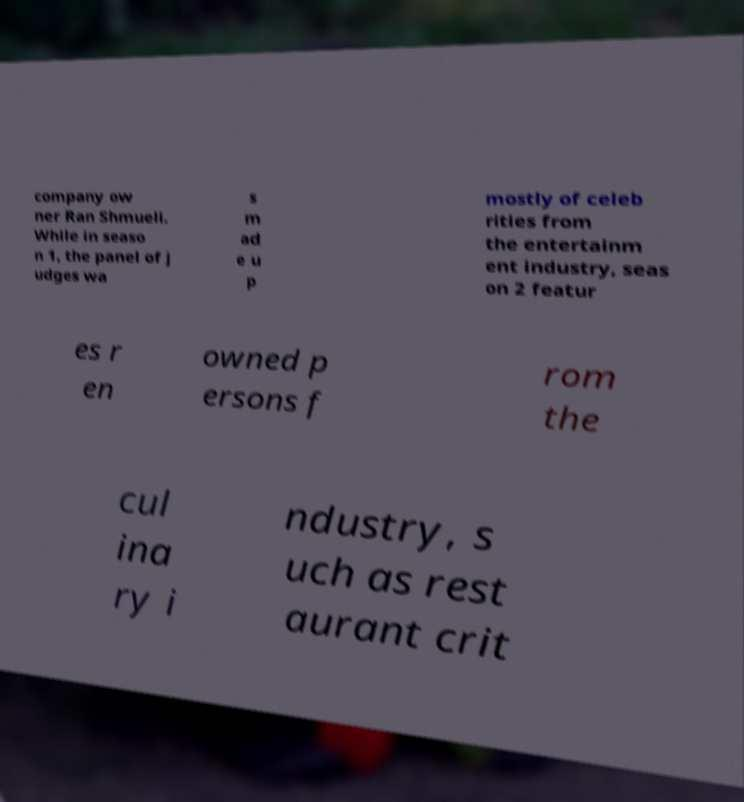For documentation purposes, I need the text within this image transcribed. Could you provide that? company ow ner Ran Shmueli. While in seaso n 1, the panel of j udges wa s m ad e u p mostly of celeb rities from the entertainm ent industry, seas on 2 featur es r en owned p ersons f rom the cul ina ry i ndustry, s uch as rest aurant crit 